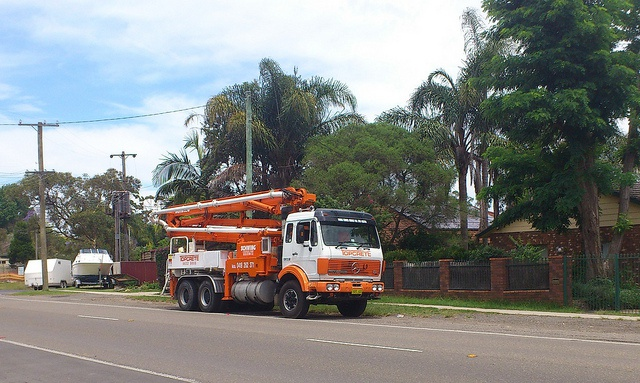Describe the objects in this image and their specific colors. I can see truck in lavender, black, lightgray, gray, and maroon tones, boat in lavender, white, gray, and darkgray tones, and people in lavender, black, maroon, and brown tones in this image. 